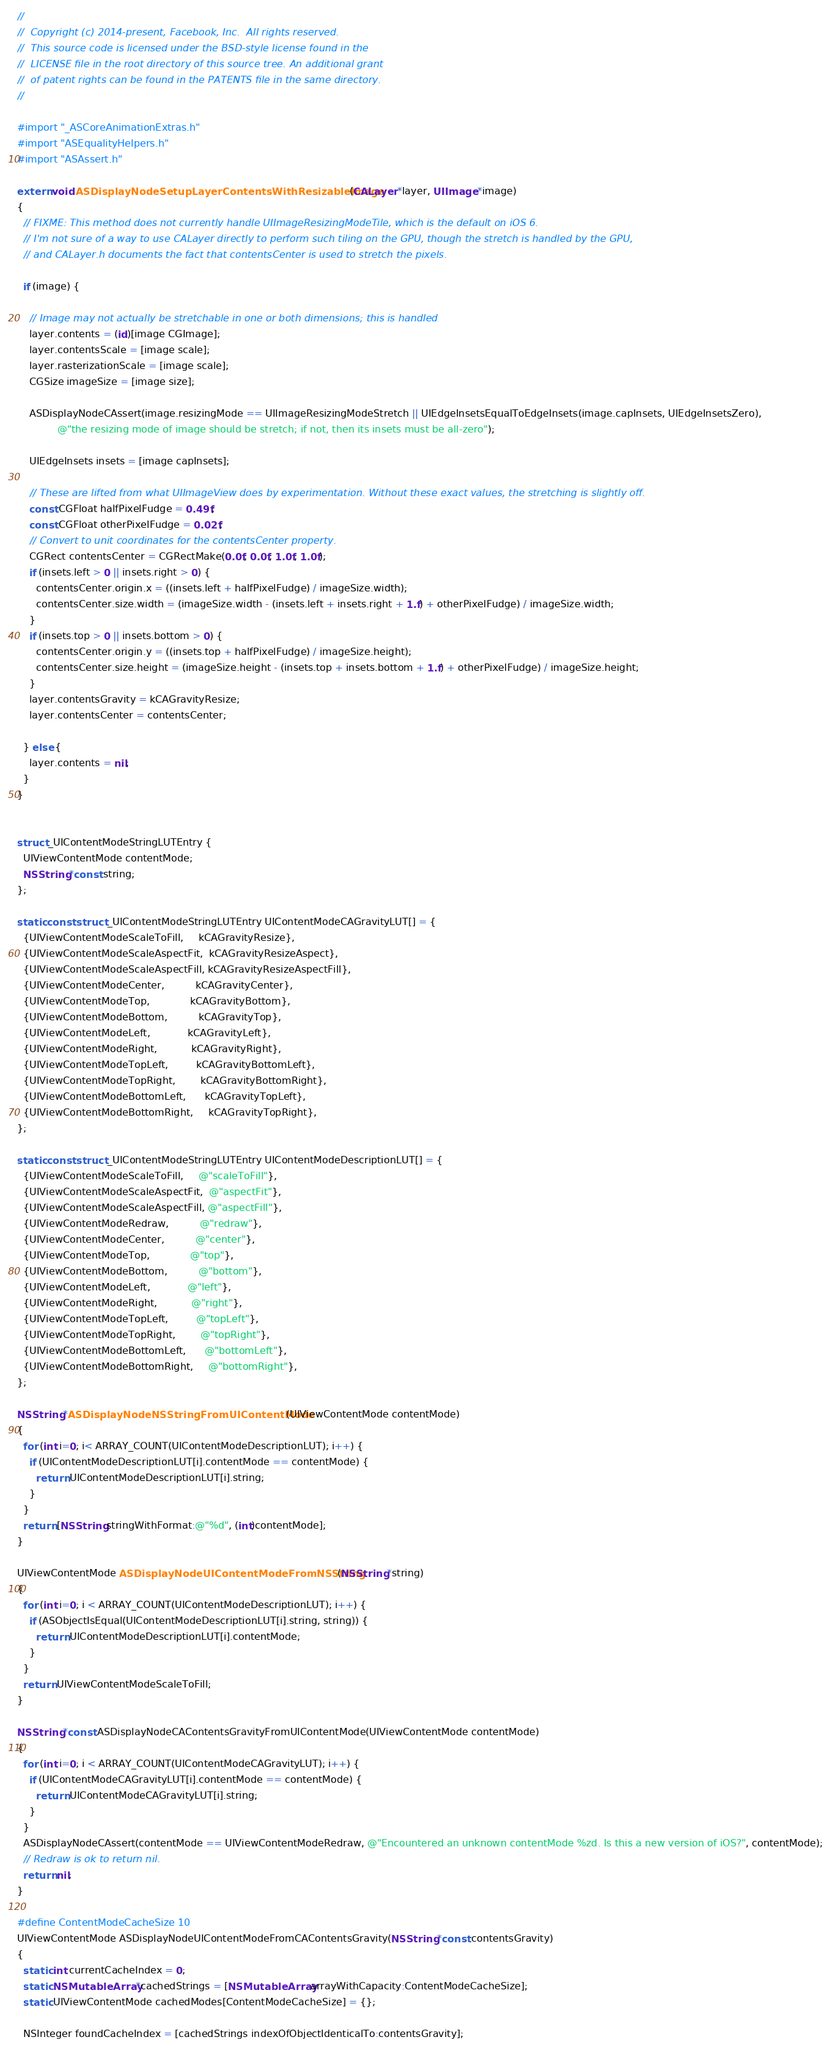<code> <loc_0><loc_0><loc_500><loc_500><_ObjectiveC_>//
//  Copyright (c) 2014-present, Facebook, Inc.  All rights reserved.
//  This source code is licensed under the BSD-style license found in the
//  LICENSE file in the root directory of this source tree. An additional grant
//  of patent rights can be found in the PATENTS file in the same directory.
//

#import "_ASCoreAnimationExtras.h"
#import "ASEqualityHelpers.h"
#import "ASAssert.h"

extern void ASDisplayNodeSetupLayerContentsWithResizableImage(CALayer *layer, UIImage *image)
{
  // FIXME: This method does not currently handle UIImageResizingModeTile, which is the default on iOS 6.
  // I'm not sure of a way to use CALayer directly to perform such tiling on the GPU, though the stretch is handled by the GPU,
  // and CALayer.h documents the fact that contentsCenter is used to stretch the pixels.

  if (image) {

    // Image may not actually be stretchable in one or both dimensions; this is handled
    layer.contents = (id)[image CGImage];
    layer.contentsScale = [image scale];
    layer.rasterizationScale = [image scale];
    CGSize imageSize = [image size];

    ASDisplayNodeCAssert(image.resizingMode == UIImageResizingModeStretch || UIEdgeInsetsEqualToEdgeInsets(image.capInsets, UIEdgeInsetsZero),
             @"the resizing mode of image should be stretch; if not, then its insets must be all-zero");

    UIEdgeInsets insets = [image capInsets];

    // These are lifted from what UIImageView does by experimentation. Without these exact values, the stretching is slightly off.
    const CGFloat halfPixelFudge = 0.49f;
    const CGFloat otherPixelFudge = 0.02f;
    // Convert to unit coordinates for the contentsCenter property.
    CGRect contentsCenter = CGRectMake(0.0f, 0.0f, 1.0f, 1.0f);
    if (insets.left > 0 || insets.right > 0) {
      contentsCenter.origin.x = ((insets.left + halfPixelFudge) / imageSize.width);
      contentsCenter.size.width = (imageSize.width - (insets.left + insets.right + 1.f) + otherPixelFudge) / imageSize.width;
    }
    if (insets.top > 0 || insets.bottom > 0) {
      contentsCenter.origin.y = ((insets.top + halfPixelFudge) / imageSize.height);
      contentsCenter.size.height = (imageSize.height - (insets.top + insets.bottom + 1.f) + otherPixelFudge) / imageSize.height;
    }
    layer.contentsGravity = kCAGravityResize;
    layer.contentsCenter = contentsCenter;

  } else {
    layer.contents = nil;
  }
}


struct _UIContentModeStringLUTEntry {
  UIViewContentMode contentMode;
  NSString *const string;
};

static const struct _UIContentModeStringLUTEntry UIContentModeCAGravityLUT[] = {
  {UIViewContentModeScaleToFill,     kCAGravityResize},
  {UIViewContentModeScaleAspectFit,  kCAGravityResizeAspect},
  {UIViewContentModeScaleAspectFill, kCAGravityResizeAspectFill},
  {UIViewContentModeCenter,          kCAGravityCenter},
  {UIViewContentModeTop,             kCAGravityBottom},
  {UIViewContentModeBottom,          kCAGravityTop},
  {UIViewContentModeLeft,            kCAGravityLeft},
  {UIViewContentModeRight,           kCAGravityRight},
  {UIViewContentModeTopLeft,         kCAGravityBottomLeft},
  {UIViewContentModeTopRight,        kCAGravityBottomRight},
  {UIViewContentModeBottomLeft,      kCAGravityTopLeft},
  {UIViewContentModeBottomRight,     kCAGravityTopRight},
};

static const struct _UIContentModeStringLUTEntry UIContentModeDescriptionLUT[] = {
  {UIViewContentModeScaleToFill,     @"scaleToFill"},
  {UIViewContentModeScaleAspectFit,  @"aspectFit"},
  {UIViewContentModeScaleAspectFill, @"aspectFill"},
  {UIViewContentModeRedraw,          @"redraw"},
  {UIViewContentModeCenter,          @"center"},
  {UIViewContentModeTop,             @"top"},
  {UIViewContentModeBottom,          @"bottom"},
  {UIViewContentModeLeft,            @"left"},
  {UIViewContentModeRight,           @"right"},
  {UIViewContentModeTopLeft,         @"topLeft"},
  {UIViewContentModeTopRight,        @"topRight"},
  {UIViewContentModeBottomLeft,      @"bottomLeft"},
  {UIViewContentModeBottomRight,     @"bottomRight"},
};

NSString *ASDisplayNodeNSStringFromUIContentMode(UIViewContentMode contentMode)
{
  for (int i=0; i< ARRAY_COUNT(UIContentModeDescriptionLUT); i++) {
    if (UIContentModeDescriptionLUT[i].contentMode == contentMode) {
      return UIContentModeDescriptionLUT[i].string;
    }
  }
  return [NSString stringWithFormat:@"%d", (int)contentMode];
}

UIViewContentMode ASDisplayNodeUIContentModeFromNSString(NSString *string)
{
  for (int i=0; i < ARRAY_COUNT(UIContentModeDescriptionLUT); i++) {
    if (ASObjectIsEqual(UIContentModeDescriptionLUT[i].string, string)) {
      return UIContentModeDescriptionLUT[i].contentMode;
    }
  }
  return UIViewContentModeScaleToFill;
}

NSString *const ASDisplayNodeCAContentsGravityFromUIContentMode(UIViewContentMode contentMode)
{
  for (int i=0; i < ARRAY_COUNT(UIContentModeCAGravityLUT); i++) {
    if (UIContentModeCAGravityLUT[i].contentMode == contentMode) {
      return UIContentModeCAGravityLUT[i].string;
    }
  }
  ASDisplayNodeCAssert(contentMode == UIViewContentModeRedraw, @"Encountered an unknown contentMode %zd. Is this a new version of iOS?", contentMode);
  // Redraw is ok to return nil.
  return nil;
}

#define ContentModeCacheSize 10
UIViewContentMode ASDisplayNodeUIContentModeFromCAContentsGravity(NSString *const contentsGravity)
{
  static int currentCacheIndex = 0;
  static NSMutableArray *cachedStrings = [NSMutableArray arrayWithCapacity:ContentModeCacheSize];
  static UIViewContentMode cachedModes[ContentModeCacheSize] = {};
  
  NSInteger foundCacheIndex = [cachedStrings indexOfObjectIdenticalTo:contentsGravity];</code> 